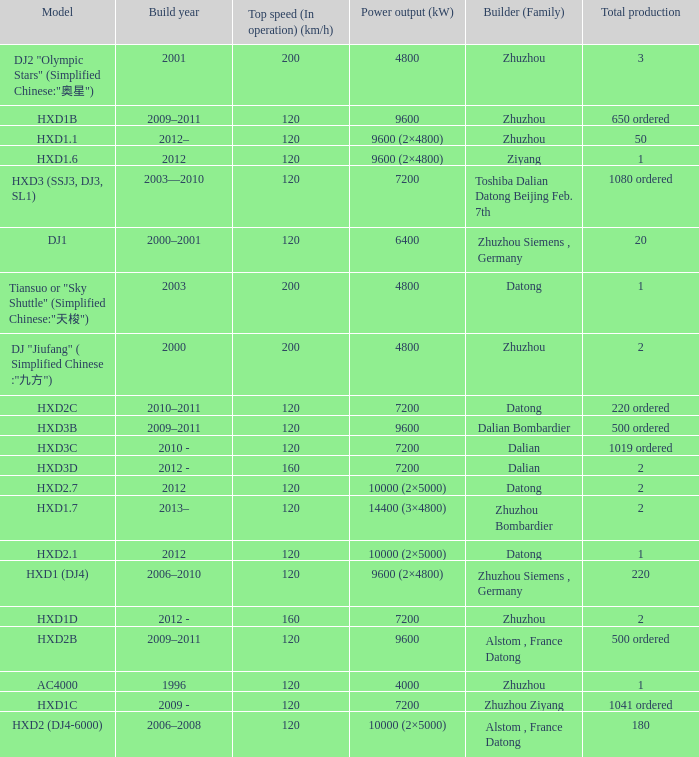What model has a builder of zhuzhou, and a power output of 9600 (kw)? HXD1B. 